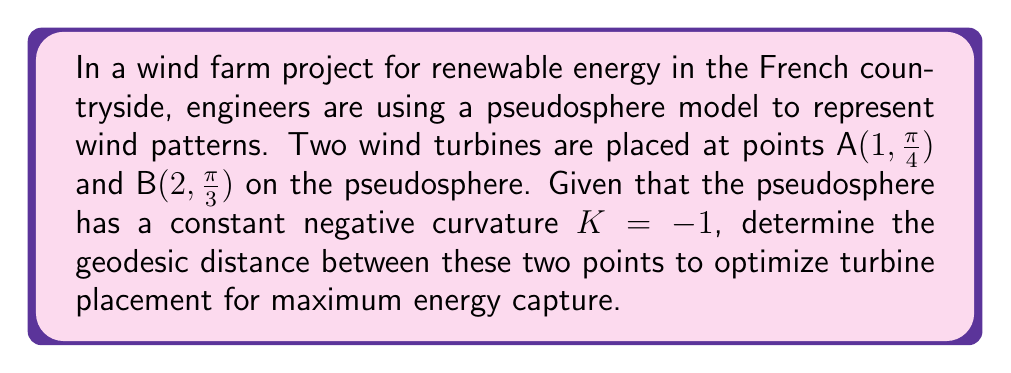Can you solve this math problem? To solve this problem, we'll use the distance formula for geodesics on a pseudosphere. The steps are as follows:

1) The distance formula for geodesics on a pseudosphere with curvature K = -1 is:

   $$\cosh d = \cosh u_1 \cosh u_2 - \sinh u_1 \sinh u_2 \cos(\theta_2 - \theta_1)$$

   where $(u_1, \theta_1)$ and $(u_2, \theta_2)$ are the coordinates of the two points.

2) We have A(1, π/4) and B(2, π/3). So:
   $u_1 = 1$, $\theta_1 = \frac{\pi}{4}$
   $u_2 = 2$, $\theta_2 = \frac{\pi}{3}$

3) Let's calculate each term:
   $\cosh u_1 = \cosh 1 \approx 1.5430$
   $\cosh u_2 = \cosh 2 \approx 3.7622$
   $\sinh u_1 = \sinh 1 \approx 1.1752$
   $\sinh u_2 = \sinh 2 \approx 3.6269$
   $\cos(\theta_2 - \theta_1) = \cos(\frac{\pi}{3} - \frac{\pi}{4}) = \cos(\frac{\pi}{12}) \approx 0.9659$

4) Substituting into the formula:
   $$\cosh d = (1.5430)(3.7622) - (1.1752)(3.6269)(0.9659)$$

5) Calculating:
   $$\cosh d = 5.8051 - 4.1189 = 1.6862$$

6) To find d, we need to apply the inverse hyperbolic cosine function:
   $$d = \text{arccosh}(1.6862) \approx 1.1385$$

This distance is in the units of the pseudosphere's radius.
Answer: $1.1385$ units 